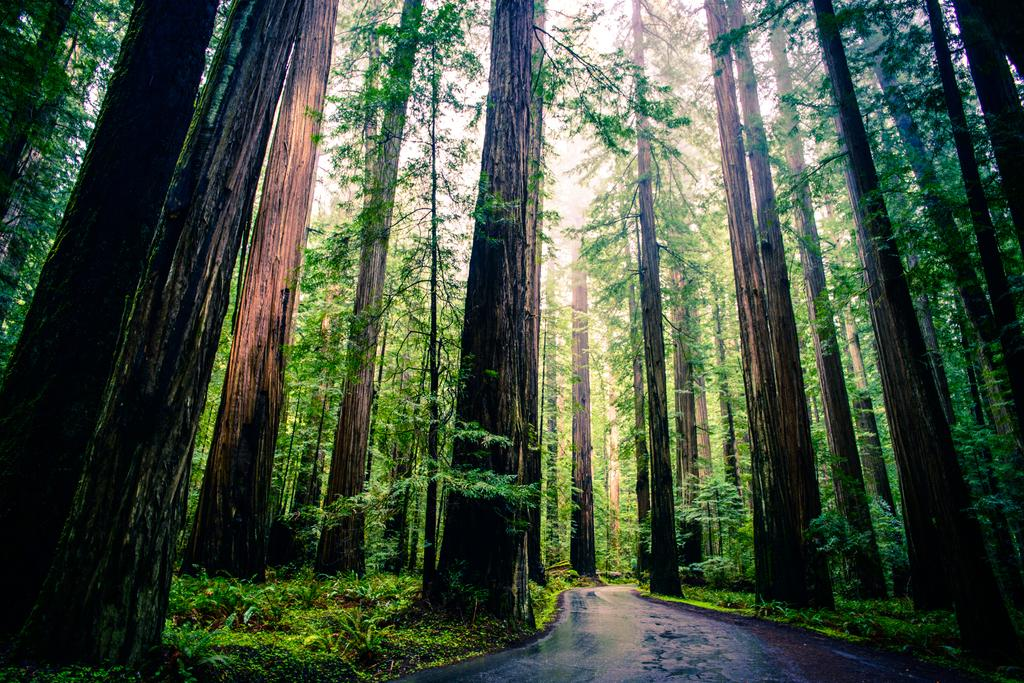What is the main feature in the center of the image? There is a road in the center of the image. What can be seen in the background of the image? There are trees, grass, and plants in the background of the image. Can you tell me how many rabbits are hopping on the road in the image? There are no rabbits present in the image; it only features a road and background elements. What is the value of the cook's apron in the image? There is no cook or apron present in the image. 